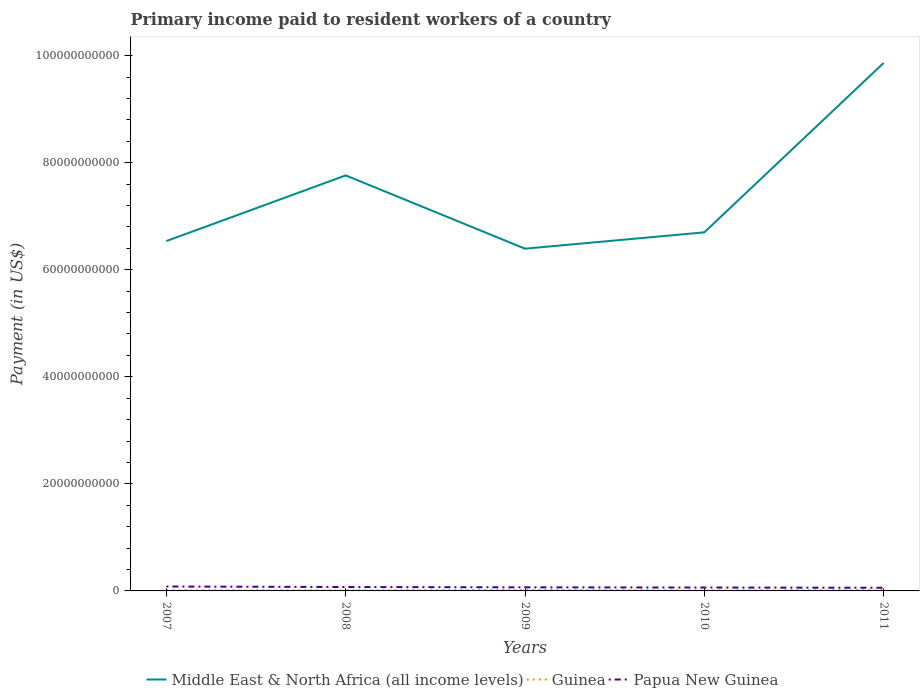How many different coloured lines are there?
Ensure brevity in your answer.  3. Does the line corresponding to Middle East & North Africa (all income levels) intersect with the line corresponding to Guinea?
Your answer should be compact. No. Across all years, what is the maximum amount paid to workers in Papua New Guinea?
Offer a very short reply. 5.91e+08. In which year was the amount paid to workers in Middle East & North Africa (all income levels) maximum?
Offer a terse response. 2009. What is the total amount paid to workers in Guinea in the graph?
Provide a succinct answer. 3.21e+07. What is the difference between the highest and the second highest amount paid to workers in Guinea?
Your response must be concise. 9.84e+07. How many lines are there?
Provide a succinct answer. 3. Are the values on the major ticks of Y-axis written in scientific E-notation?
Provide a short and direct response. No. Does the graph contain any zero values?
Your response must be concise. No. How many legend labels are there?
Your answer should be very brief. 3. How are the legend labels stacked?
Ensure brevity in your answer.  Horizontal. What is the title of the graph?
Give a very brief answer. Primary income paid to resident workers of a country. Does "Czech Republic" appear as one of the legend labels in the graph?
Provide a succinct answer. No. What is the label or title of the X-axis?
Your response must be concise. Years. What is the label or title of the Y-axis?
Offer a very short reply. Payment (in US$). What is the Payment (in US$) of Middle East & North Africa (all income levels) in 2007?
Keep it short and to the point. 6.54e+1. What is the Payment (in US$) in Guinea in 2007?
Provide a short and direct response. 1.24e+08. What is the Payment (in US$) in Papua New Guinea in 2007?
Offer a very short reply. 8.24e+08. What is the Payment (in US$) in Middle East & North Africa (all income levels) in 2008?
Give a very brief answer. 7.76e+1. What is the Payment (in US$) of Guinea in 2008?
Provide a succinct answer. 1.01e+08. What is the Payment (in US$) of Papua New Guinea in 2008?
Keep it short and to the point. 7.29e+08. What is the Payment (in US$) in Middle East & North Africa (all income levels) in 2009?
Offer a very short reply. 6.39e+1. What is the Payment (in US$) of Guinea in 2009?
Offer a very short reply. 1.90e+08. What is the Payment (in US$) of Papua New Guinea in 2009?
Keep it short and to the point. 6.71e+08. What is the Payment (in US$) of Middle East & North Africa (all income levels) in 2010?
Provide a succinct answer. 6.70e+1. What is the Payment (in US$) in Guinea in 2010?
Make the answer very short. 9.20e+07. What is the Payment (in US$) in Papua New Guinea in 2010?
Offer a terse response. 6.34e+08. What is the Payment (in US$) in Middle East & North Africa (all income levels) in 2011?
Ensure brevity in your answer.  9.86e+1. What is the Payment (in US$) in Guinea in 2011?
Make the answer very short. 1.56e+08. What is the Payment (in US$) of Papua New Guinea in 2011?
Keep it short and to the point. 5.91e+08. Across all years, what is the maximum Payment (in US$) of Middle East & North Africa (all income levels)?
Provide a short and direct response. 9.86e+1. Across all years, what is the maximum Payment (in US$) of Guinea?
Offer a terse response. 1.90e+08. Across all years, what is the maximum Payment (in US$) of Papua New Guinea?
Make the answer very short. 8.24e+08. Across all years, what is the minimum Payment (in US$) in Middle East & North Africa (all income levels)?
Keep it short and to the point. 6.39e+1. Across all years, what is the minimum Payment (in US$) in Guinea?
Keep it short and to the point. 9.20e+07. Across all years, what is the minimum Payment (in US$) of Papua New Guinea?
Keep it short and to the point. 5.91e+08. What is the total Payment (in US$) of Middle East & North Africa (all income levels) in the graph?
Offer a very short reply. 3.73e+11. What is the total Payment (in US$) in Guinea in the graph?
Offer a terse response. 6.63e+08. What is the total Payment (in US$) in Papua New Guinea in the graph?
Offer a terse response. 3.45e+09. What is the difference between the Payment (in US$) of Middle East & North Africa (all income levels) in 2007 and that in 2008?
Keep it short and to the point. -1.23e+1. What is the difference between the Payment (in US$) in Guinea in 2007 and that in 2008?
Provide a short and direct response. 2.31e+07. What is the difference between the Payment (in US$) of Papua New Guinea in 2007 and that in 2008?
Offer a terse response. 9.48e+07. What is the difference between the Payment (in US$) of Middle East & North Africa (all income levels) in 2007 and that in 2009?
Your response must be concise. 1.42e+09. What is the difference between the Payment (in US$) of Guinea in 2007 and that in 2009?
Provide a short and direct response. -6.63e+07. What is the difference between the Payment (in US$) of Papua New Guinea in 2007 and that in 2009?
Provide a succinct answer. 1.53e+08. What is the difference between the Payment (in US$) of Middle East & North Africa (all income levels) in 2007 and that in 2010?
Give a very brief answer. -1.63e+09. What is the difference between the Payment (in US$) in Guinea in 2007 and that in 2010?
Your answer should be very brief. 3.21e+07. What is the difference between the Payment (in US$) of Papua New Guinea in 2007 and that in 2010?
Your answer should be compact. 1.90e+08. What is the difference between the Payment (in US$) in Middle East & North Africa (all income levels) in 2007 and that in 2011?
Offer a very short reply. -3.33e+1. What is the difference between the Payment (in US$) of Guinea in 2007 and that in 2011?
Keep it short and to the point. -3.15e+07. What is the difference between the Payment (in US$) in Papua New Guinea in 2007 and that in 2011?
Your answer should be very brief. 2.33e+08. What is the difference between the Payment (in US$) of Middle East & North Africa (all income levels) in 2008 and that in 2009?
Ensure brevity in your answer.  1.37e+1. What is the difference between the Payment (in US$) of Guinea in 2008 and that in 2009?
Your answer should be very brief. -8.94e+07. What is the difference between the Payment (in US$) in Papua New Guinea in 2008 and that in 2009?
Ensure brevity in your answer.  5.81e+07. What is the difference between the Payment (in US$) in Middle East & North Africa (all income levels) in 2008 and that in 2010?
Offer a terse response. 1.06e+1. What is the difference between the Payment (in US$) of Guinea in 2008 and that in 2010?
Your response must be concise. 9.01e+06. What is the difference between the Payment (in US$) of Papua New Guinea in 2008 and that in 2010?
Your answer should be compact. 9.52e+07. What is the difference between the Payment (in US$) of Middle East & North Africa (all income levels) in 2008 and that in 2011?
Provide a succinct answer. -2.10e+1. What is the difference between the Payment (in US$) in Guinea in 2008 and that in 2011?
Offer a very short reply. -5.46e+07. What is the difference between the Payment (in US$) in Papua New Guinea in 2008 and that in 2011?
Make the answer very short. 1.39e+08. What is the difference between the Payment (in US$) in Middle East & North Africa (all income levels) in 2009 and that in 2010?
Ensure brevity in your answer.  -3.05e+09. What is the difference between the Payment (in US$) of Guinea in 2009 and that in 2010?
Your answer should be compact. 9.84e+07. What is the difference between the Payment (in US$) of Papua New Guinea in 2009 and that in 2010?
Offer a terse response. 3.71e+07. What is the difference between the Payment (in US$) of Middle East & North Africa (all income levels) in 2009 and that in 2011?
Give a very brief answer. -3.47e+1. What is the difference between the Payment (in US$) in Guinea in 2009 and that in 2011?
Offer a terse response. 3.48e+07. What is the difference between the Payment (in US$) of Papua New Guinea in 2009 and that in 2011?
Provide a short and direct response. 8.04e+07. What is the difference between the Payment (in US$) in Middle East & North Africa (all income levels) in 2010 and that in 2011?
Keep it short and to the point. -3.16e+1. What is the difference between the Payment (in US$) of Guinea in 2010 and that in 2011?
Give a very brief answer. -6.36e+07. What is the difference between the Payment (in US$) of Papua New Guinea in 2010 and that in 2011?
Your answer should be very brief. 4.33e+07. What is the difference between the Payment (in US$) of Middle East & North Africa (all income levels) in 2007 and the Payment (in US$) of Guinea in 2008?
Give a very brief answer. 6.53e+1. What is the difference between the Payment (in US$) of Middle East & North Africa (all income levels) in 2007 and the Payment (in US$) of Papua New Guinea in 2008?
Your response must be concise. 6.46e+1. What is the difference between the Payment (in US$) of Guinea in 2007 and the Payment (in US$) of Papua New Guinea in 2008?
Offer a terse response. -6.05e+08. What is the difference between the Payment (in US$) in Middle East & North Africa (all income levels) in 2007 and the Payment (in US$) in Guinea in 2009?
Give a very brief answer. 6.52e+1. What is the difference between the Payment (in US$) in Middle East & North Africa (all income levels) in 2007 and the Payment (in US$) in Papua New Guinea in 2009?
Keep it short and to the point. 6.47e+1. What is the difference between the Payment (in US$) of Guinea in 2007 and the Payment (in US$) of Papua New Guinea in 2009?
Make the answer very short. -5.47e+08. What is the difference between the Payment (in US$) in Middle East & North Africa (all income levels) in 2007 and the Payment (in US$) in Guinea in 2010?
Make the answer very short. 6.53e+1. What is the difference between the Payment (in US$) in Middle East & North Africa (all income levels) in 2007 and the Payment (in US$) in Papua New Guinea in 2010?
Your answer should be compact. 6.47e+1. What is the difference between the Payment (in US$) in Guinea in 2007 and the Payment (in US$) in Papua New Guinea in 2010?
Ensure brevity in your answer.  -5.10e+08. What is the difference between the Payment (in US$) in Middle East & North Africa (all income levels) in 2007 and the Payment (in US$) in Guinea in 2011?
Keep it short and to the point. 6.52e+1. What is the difference between the Payment (in US$) in Middle East & North Africa (all income levels) in 2007 and the Payment (in US$) in Papua New Guinea in 2011?
Your answer should be very brief. 6.48e+1. What is the difference between the Payment (in US$) in Guinea in 2007 and the Payment (in US$) in Papua New Guinea in 2011?
Make the answer very short. -4.67e+08. What is the difference between the Payment (in US$) of Middle East & North Africa (all income levels) in 2008 and the Payment (in US$) of Guinea in 2009?
Provide a short and direct response. 7.74e+1. What is the difference between the Payment (in US$) of Middle East & North Africa (all income levels) in 2008 and the Payment (in US$) of Papua New Guinea in 2009?
Offer a very short reply. 7.70e+1. What is the difference between the Payment (in US$) of Guinea in 2008 and the Payment (in US$) of Papua New Guinea in 2009?
Your answer should be compact. -5.70e+08. What is the difference between the Payment (in US$) in Middle East & North Africa (all income levels) in 2008 and the Payment (in US$) in Guinea in 2010?
Provide a short and direct response. 7.75e+1. What is the difference between the Payment (in US$) of Middle East & North Africa (all income levels) in 2008 and the Payment (in US$) of Papua New Guinea in 2010?
Your answer should be very brief. 7.70e+1. What is the difference between the Payment (in US$) of Guinea in 2008 and the Payment (in US$) of Papua New Guinea in 2010?
Your answer should be compact. -5.33e+08. What is the difference between the Payment (in US$) in Middle East & North Africa (all income levels) in 2008 and the Payment (in US$) in Guinea in 2011?
Ensure brevity in your answer.  7.75e+1. What is the difference between the Payment (in US$) in Middle East & North Africa (all income levels) in 2008 and the Payment (in US$) in Papua New Guinea in 2011?
Provide a succinct answer. 7.70e+1. What is the difference between the Payment (in US$) in Guinea in 2008 and the Payment (in US$) in Papua New Guinea in 2011?
Your response must be concise. -4.90e+08. What is the difference between the Payment (in US$) in Middle East & North Africa (all income levels) in 2009 and the Payment (in US$) in Guinea in 2010?
Provide a short and direct response. 6.38e+1. What is the difference between the Payment (in US$) of Middle East & North Africa (all income levels) in 2009 and the Payment (in US$) of Papua New Guinea in 2010?
Your answer should be very brief. 6.33e+1. What is the difference between the Payment (in US$) of Guinea in 2009 and the Payment (in US$) of Papua New Guinea in 2010?
Provide a short and direct response. -4.44e+08. What is the difference between the Payment (in US$) in Middle East & North Africa (all income levels) in 2009 and the Payment (in US$) in Guinea in 2011?
Offer a very short reply. 6.38e+1. What is the difference between the Payment (in US$) in Middle East & North Africa (all income levels) in 2009 and the Payment (in US$) in Papua New Guinea in 2011?
Keep it short and to the point. 6.33e+1. What is the difference between the Payment (in US$) in Guinea in 2009 and the Payment (in US$) in Papua New Guinea in 2011?
Your response must be concise. -4.00e+08. What is the difference between the Payment (in US$) in Middle East & North Africa (all income levels) in 2010 and the Payment (in US$) in Guinea in 2011?
Keep it short and to the point. 6.68e+1. What is the difference between the Payment (in US$) in Middle East & North Africa (all income levels) in 2010 and the Payment (in US$) in Papua New Guinea in 2011?
Your answer should be very brief. 6.64e+1. What is the difference between the Payment (in US$) of Guinea in 2010 and the Payment (in US$) of Papua New Guinea in 2011?
Ensure brevity in your answer.  -4.99e+08. What is the average Payment (in US$) in Middle East & North Africa (all income levels) per year?
Make the answer very short. 7.45e+1. What is the average Payment (in US$) of Guinea per year?
Ensure brevity in your answer.  1.33e+08. What is the average Payment (in US$) of Papua New Guinea per year?
Your answer should be very brief. 6.90e+08. In the year 2007, what is the difference between the Payment (in US$) of Middle East & North Africa (all income levels) and Payment (in US$) of Guinea?
Your answer should be compact. 6.52e+1. In the year 2007, what is the difference between the Payment (in US$) in Middle East & North Africa (all income levels) and Payment (in US$) in Papua New Guinea?
Your answer should be compact. 6.45e+1. In the year 2007, what is the difference between the Payment (in US$) in Guinea and Payment (in US$) in Papua New Guinea?
Your answer should be very brief. -7.00e+08. In the year 2008, what is the difference between the Payment (in US$) of Middle East & North Africa (all income levels) and Payment (in US$) of Guinea?
Keep it short and to the point. 7.75e+1. In the year 2008, what is the difference between the Payment (in US$) in Middle East & North Africa (all income levels) and Payment (in US$) in Papua New Guinea?
Your response must be concise. 7.69e+1. In the year 2008, what is the difference between the Payment (in US$) of Guinea and Payment (in US$) of Papua New Guinea?
Ensure brevity in your answer.  -6.28e+08. In the year 2009, what is the difference between the Payment (in US$) in Middle East & North Africa (all income levels) and Payment (in US$) in Guinea?
Offer a terse response. 6.37e+1. In the year 2009, what is the difference between the Payment (in US$) in Middle East & North Africa (all income levels) and Payment (in US$) in Papua New Guinea?
Your response must be concise. 6.33e+1. In the year 2009, what is the difference between the Payment (in US$) of Guinea and Payment (in US$) of Papua New Guinea?
Keep it short and to the point. -4.81e+08. In the year 2010, what is the difference between the Payment (in US$) of Middle East & North Africa (all income levels) and Payment (in US$) of Guinea?
Make the answer very short. 6.69e+1. In the year 2010, what is the difference between the Payment (in US$) of Middle East & North Africa (all income levels) and Payment (in US$) of Papua New Guinea?
Your answer should be very brief. 6.64e+1. In the year 2010, what is the difference between the Payment (in US$) in Guinea and Payment (in US$) in Papua New Guinea?
Keep it short and to the point. -5.42e+08. In the year 2011, what is the difference between the Payment (in US$) of Middle East & North Africa (all income levels) and Payment (in US$) of Guinea?
Keep it short and to the point. 9.85e+1. In the year 2011, what is the difference between the Payment (in US$) in Middle East & North Africa (all income levels) and Payment (in US$) in Papua New Guinea?
Your response must be concise. 9.80e+1. In the year 2011, what is the difference between the Payment (in US$) in Guinea and Payment (in US$) in Papua New Guinea?
Offer a very short reply. -4.35e+08. What is the ratio of the Payment (in US$) of Middle East & North Africa (all income levels) in 2007 to that in 2008?
Offer a terse response. 0.84. What is the ratio of the Payment (in US$) of Guinea in 2007 to that in 2008?
Keep it short and to the point. 1.23. What is the ratio of the Payment (in US$) of Papua New Guinea in 2007 to that in 2008?
Ensure brevity in your answer.  1.13. What is the ratio of the Payment (in US$) of Middle East & North Africa (all income levels) in 2007 to that in 2009?
Give a very brief answer. 1.02. What is the ratio of the Payment (in US$) of Guinea in 2007 to that in 2009?
Provide a short and direct response. 0.65. What is the ratio of the Payment (in US$) of Papua New Guinea in 2007 to that in 2009?
Your answer should be very brief. 1.23. What is the ratio of the Payment (in US$) in Middle East & North Africa (all income levels) in 2007 to that in 2010?
Your answer should be very brief. 0.98. What is the ratio of the Payment (in US$) of Guinea in 2007 to that in 2010?
Make the answer very short. 1.35. What is the ratio of the Payment (in US$) of Papua New Guinea in 2007 to that in 2010?
Provide a succinct answer. 1.3. What is the ratio of the Payment (in US$) of Middle East & North Africa (all income levels) in 2007 to that in 2011?
Provide a succinct answer. 0.66. What is the ratio of the Payment (in US$) of Guinea in 2007 to that in 2011?
Keep it short and to the point. 0.8. What is the ratio of the Payment (in US$) in Papua New Guinea in 2007 to that in 2011?
Your answer should be compact. 1.39. What is the ratio of the Payment (in US$) in Middle East & North Africa (all income levels) in 2008 to that in 2009?
Provide a short and direct response. 1.21. What is the ratio of the Payment (in US$) of Guinea in 2008 to that in 2009?
Ensure brevity in your answer.  0.53. What is the ratio of the Payment (in US$) in Papua New Guinea in 2008 to that in 2009?
Your answer should be compact. 1.09. What is the ratio of the Payment (in US$) of Middle East & North Africa (all income levels) in 2008 to that in 2010?
Keep it short and to the point. 1.16. What is the ratio of the Payment (in US$) in Guinea in 2008 to that in 2010?
Give a very brief answer. 1.1. What is the ratio of the Payment (in US$) in Papua New Guinea in 2008 to that in 2010?
Provide a succinct answer. 1.15. What is the ratio of the Payment (in US$) of Middle East & North Africa (all income levels) in 2008 to that in 2011?
Keep it short and to the point. 0.79. What is the ratio of the Payment (in US$) of Guinea in 2008 to that in 2011?
Offer a very short reply. 0.65. What is the ratio of the Payment (in US$) of Papua New Guinea in 2008 to that in 2011?
Keep it short and to the point. 1.23. What is the ratio of the Payment (in US$) of Middle East & North Africa (all income levels) in 2009 to that in 2010?
Make the answer very short. 0.95. What is the ratio of the Payment (in US$) in Guinea in 2009 to that in 2010?
Give a very brief answer. 2.07. What is the ratio of the Payment (in US$) of Papua New Guinea in 2009 to that in 2010?
Your answer should be compact. 1.06. What is the ratio of the Payment (in US$) of Middle East & North Africa (all income levels) in 2009 to that in 2011?
Offer a very short reply. 0.65. What is the ratio of the Payment (in US$) in Guinea in 2009 to that in 2011?
Your response must be concise. 1.22. What is the ratio of the Payment (in US$) of Papua New Guinea in 2009 to that in 2011?
Ensure brevity in your answer.  1.14. What is the ratio of the Payment (in US$) in Middle East & North Africa (all income levels) in 2010 to that in 2011?
Provide a succinct answer. 0.68. What is the ratio of the Payment (in US$) of Guinea in 2010 to that in 2011?
Ensure brevity in your answer.  0.59. What is the ratio of the Payment (in US$) of Papua New Guinea in 2010 to that in 2011?
Offer a very short reply. 1.07. What is the difference between the highest and the second highest Payment (in US$) in Middle East & North Africa (all income levels)?
Your answer should be compact. 2.10e+1. What is the difference between the highest and the second highest Payment (in US$) of Guinea?
Keep it short and to the point. 3.48e+07. What is the difference between the highest and the second highest Payment (in US$) of Papua New Guinea?
Provide a succinct answer. 9.48e+07. What is the difference between the highest and the lowest Payment (in US$) of Middle East & North Africa (all income levels)?
Provide a succinct answer. 3.47e+1. What is the difference between the highest and the lowest Payment (in US$) in Guinea?
Your answer should be compact. 9.84e+07. What is the difference between the highest and the lowest Payment (in US$) of Papua New Guinea?
Provide a succinct answer. 2.33e+08. 